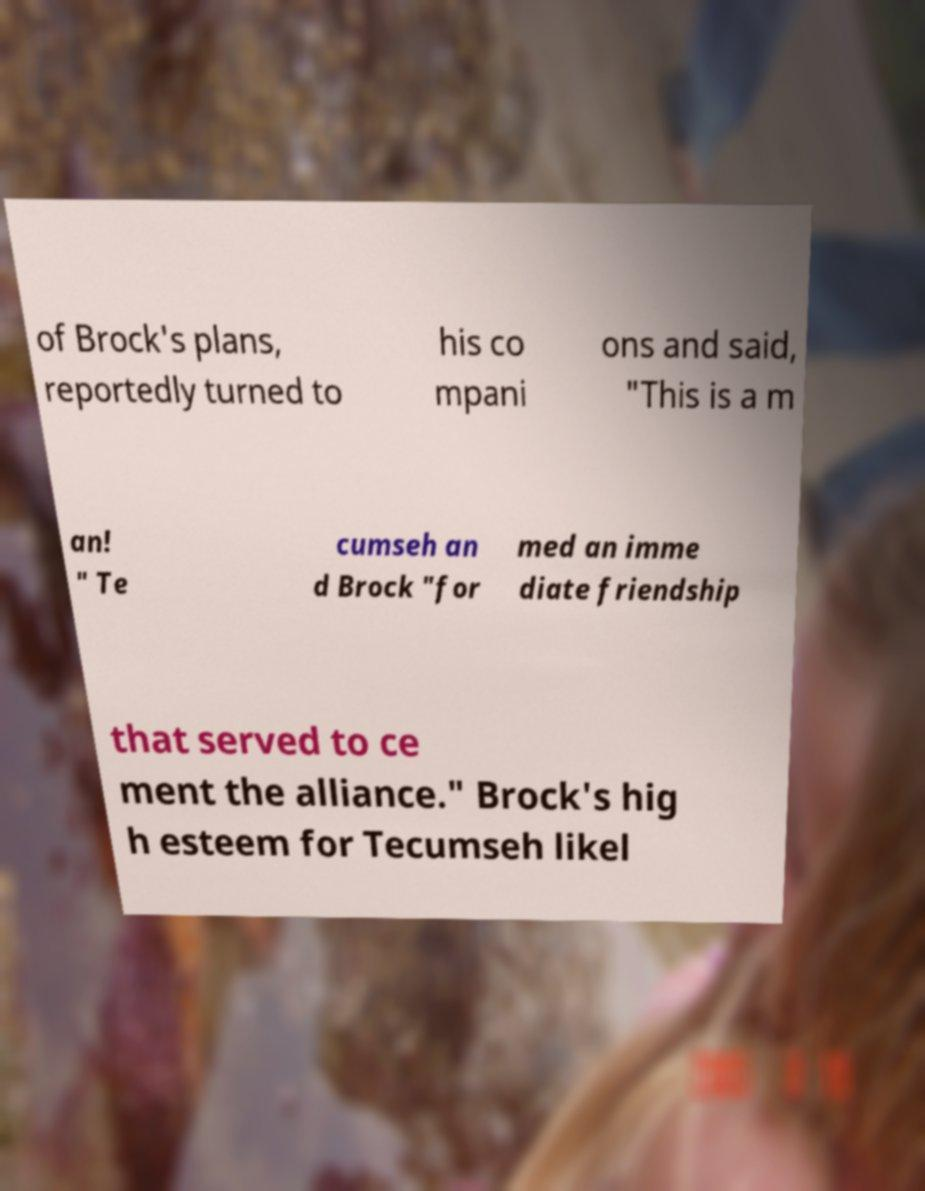Please identify and transcribe the text found in this image. of Brock's plans, reportedly turned to his co mpani ons and said, "This is a m an! " Te cumseh an d Brock "for med an imme diate friendship that served to ce ment the alliance." Brock's hig h esteem for Tecumseh likel 